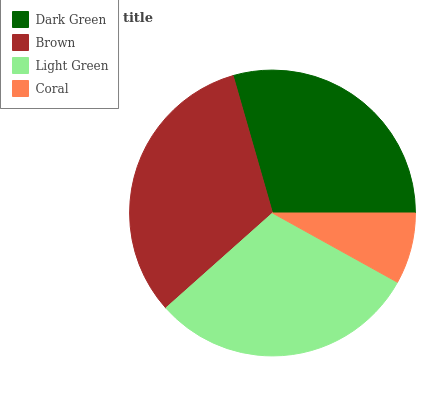Is Coral the minimum?
Answer yes or no. Yes. Is Brown the maximum?
Answer yes or no. Yes. Is Light Green the minimum?
Answer yes or no. No. Is Light Green the maximum?
Answer yes or no. No. Is Brown greater than Light Green?
Answer yes or no. Yes. Is Light Green less than Brown?
Answer yes or no. Yes. Is Light Green greater than Brown?
Answer yes or no. No. Is Brown less than Light Green?
Answer yes or no. No. Is Light Green the high median?
Answer yes or no. Yes. Is Dark Green the low median?
Answer yes or no. Yes. Is Brown the high median?
Answer yes or no. No. Is Light Green the low median?
Answer yes or no. No. 